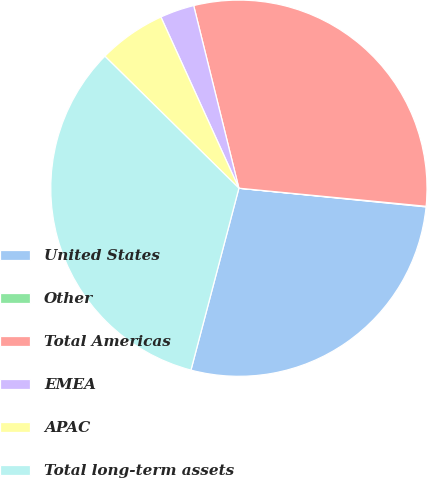Convert chart. <chart><loc_0><loc_0><loc_500><loc_500><pie_chart><fcel>United States<fcel>Other<fcel>Total Americas<fcel>EMEA<fcel>APAC<fcel>Total long-term assets<nl><fcel>27.52%<fcel>0.05%<fcel>30.4%<fcel>2.94%<fcel>5.82%<fcel>33.28%<nl></chart> 